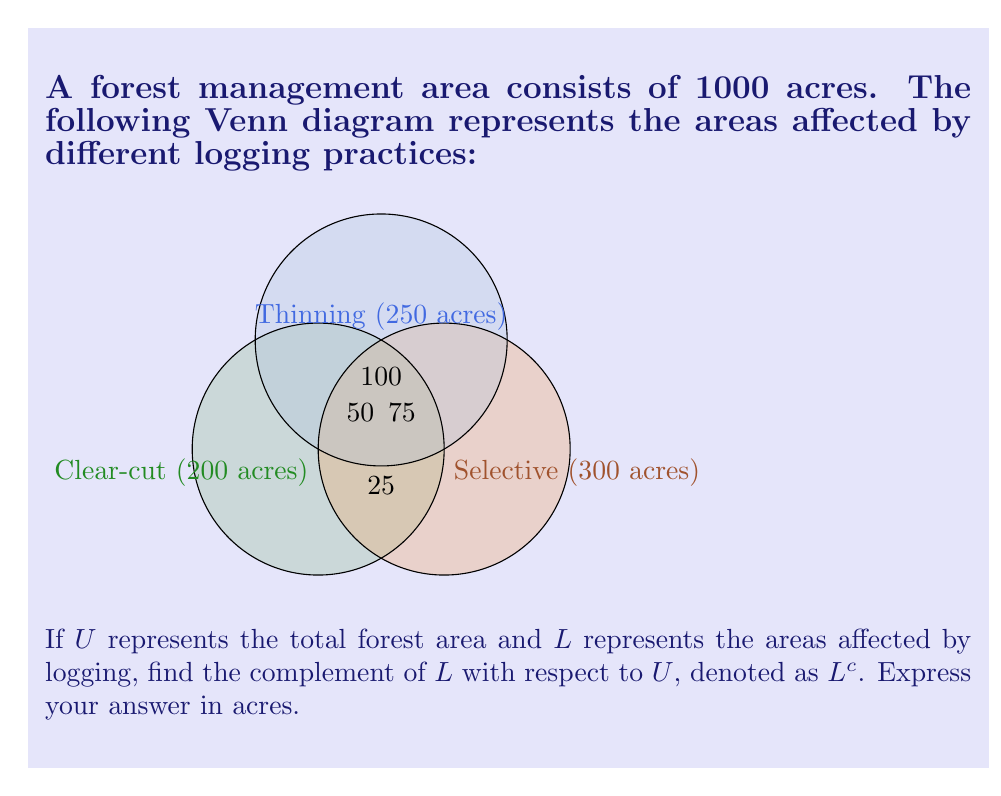Can you solve this math problem? To find the complement of set $L$ with respect to $U$, we need to:

1. Calculate the total area affected by logging (set $L$).
2. Subtract this area from the total forest area (set $U$).

Step 1: Calculate the area affected by logging

Clear-cut only: 200 - 50 - 25 - 25 = 100 acres
Selective only: 300 - 75 - 25 - 75 = 125 acres
Thinning only: 250 - 100 - 50 - 75 = 25 acres
Clear-cut and Selective: 25 acres
Clear-cut and Thinning: 50 acres
Selective and Thinning: 75 acres
All three: 25 acres

Total affected area = 100 + 125 + 25 + 25 + 50 + 75 + 25 = 425 acres

Step 2: Calculate the complement

$L^c = U - L = 1000 - 425 = 575$ acres

Therefore, the area not affected by logging (the complement of $L$) is 575 acres.
Answer: 575 acres 